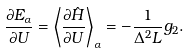<formula> <loc_0><loc_0><loc_500><loc_500>\frac { \partial E _ { \alpha } } { \partial U } = \left \langle \frac { \partial \hat { H } } { \partial U } \right \rangle _ { \alpha } = - \frac { 1 } { \Delta ^ { 2 } L } g _ { 2 } .</formula> 